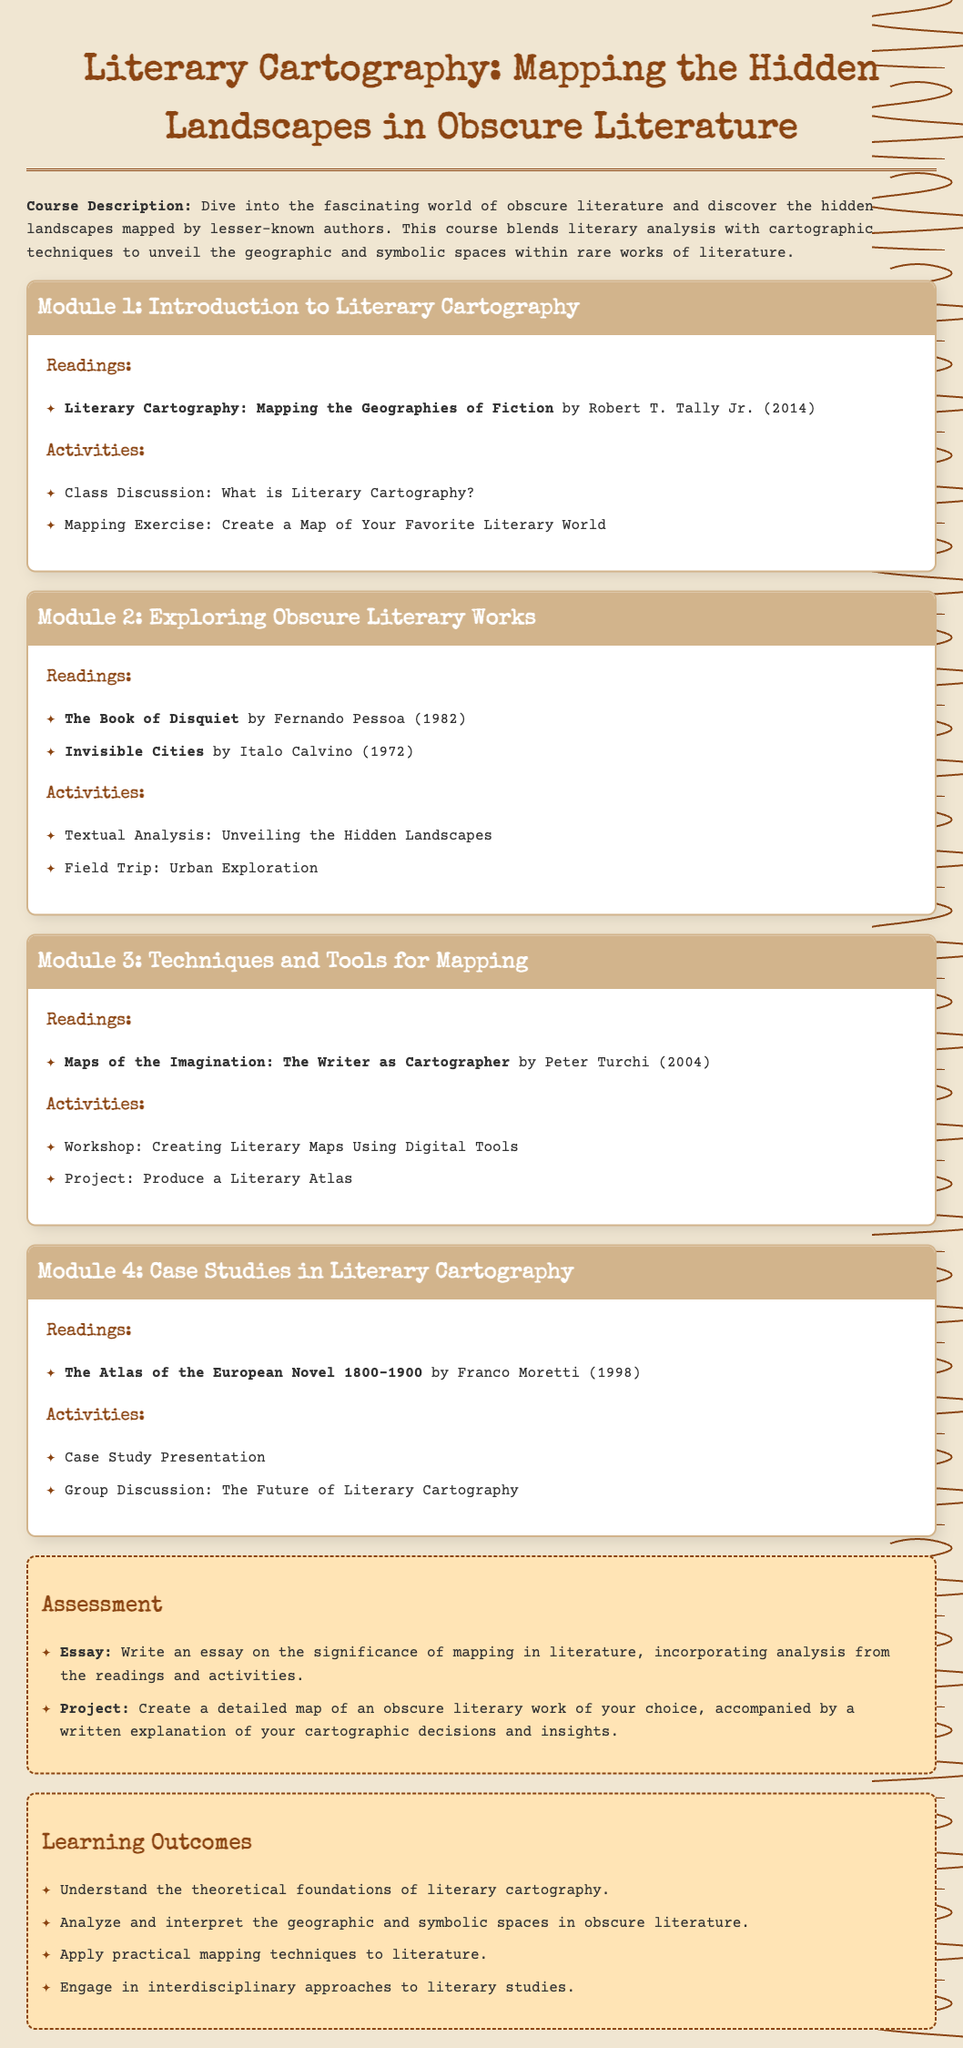What is the title of the course? The title of the course is explicitly mentioned at the beginning of the document as "Literary Cartography: Mapping the Hidden Landscapes in Obscure Literature."
Answer: Literary Cartography: Mapping the Hidden Landscapes in Obscure Literature Who is the author of "The Book of Disquiet"? The syllabus includes the reading "The Book of Disquiet," which is authored by Fernando Pessoa, noted in the readings section of Module 2.
Answer: Fernando Pessoa What year was "Invisible Cities" published? The publication year of "Invisible Cities" by Italo Calvino is noted in the syllabus under the readings in Module 2 as 1972.
Answer: 1972 How many modules are there in the syllabus? The syllabus consists of four modules, each with different themes and activities.
Answer: 4 What type of project is assigned in the assessment section? One of the projects in the assessment section is to "Create a detailed map of an obscure literary work," highlighting the focus on mapping as part of the course's objectives.
Answer: Create a detailed map of an obscure literary work What is one of the learning outcomes related to interdisciplinary studies? The document lists "Engage in interdisciplinary approaches to literary studies" as a specific learning outcome, indicating the course's broad educational goals.
Answer: Engage in interdisciplinary approaches to literary studies Which author wrote "Maps of the Imagination: The Writer as Cartographer"? The syllabus specifies that "Maps of the Imagination: The Writer as Cartographer" is written by Peter Turchi, provided in the readings for Module 3.
Answer: Peter Turchi 